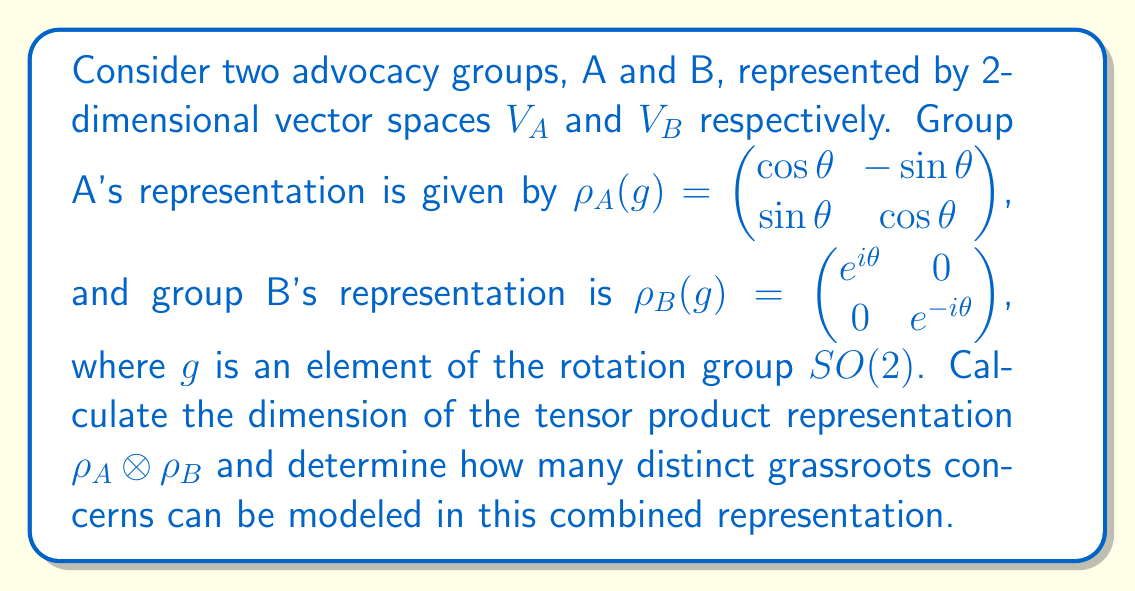Could you help me with this problem? To solve this problem, we'll follow these steps:

1) First, recall that the dimension of a tensor product of two vector spaces is the product of their individual dimensions:

   $\dim(V_A \otimes V_B) = \dim(V_A) \cdot \dim(V_B)$

2) We're given that both $V_A$ and $V_B$ are 2-dimensional vector spaces. Therefore:

   $\dim(V_A \otimes V_B) = 2 \cdot 2 = 4$

3) The tensor product representation $\rho_A \otimes \rho_B$ acts on this 4-dimensional space.

4) To determine how many distinct concerns can be modeled, we need to consider the structure of this representation. The tensor product of these two representations will be:

   $(\rho_A \otimes \rho_B)(g) = \rho_A(g) \otimes \rho_B(g)$

   $= \begin{pmatrix} 
   \cos\theta e^{i\theta} & -\sin\theta e^{i\theta} & 0 & 0 \\
   \sin\theta e^{i\theta} & \cos\theta e^{i\theta} & 0 & 0 \\
   0 & 0 & \cos\theta e^{-i\theta} & -\sin\theta e^{-i\theta} \\
   0 & 0 & \sin\theta e^{-i\theta} & \cos\theta e^{-i\theta}
   \end{pmatrix}$

5) This matrix has a block diagonal form, with two 2x2 blocks. Each block represents a distinct subspace that is invariant under the action of the group.

6) Therefore, this representation can model two distinct types of combined concerns, each corresponding to one of these invariant subspaces.

Thus, while the representation is 4-dimensional, it can model 2 distinct types of combined grassroots concerns.
Answer: Dimension: 4; Distinct concerns: 2 